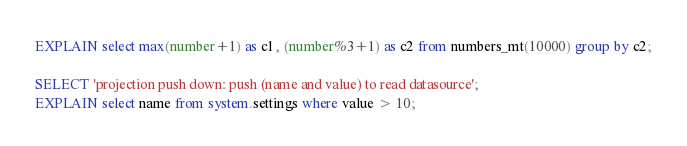Convert code to text. <code><loc_0><loc_0><loc_500><loc_500><_SQL_>EXPLAIN select max(number+1) as c1, (number%3+1) as c2 from numbers_mt(10000) group by c2;

SELECT 'projection push down: push (name and value) to read datasource';
EXPLAIN select name from system.settings where value > 10;
</code> 